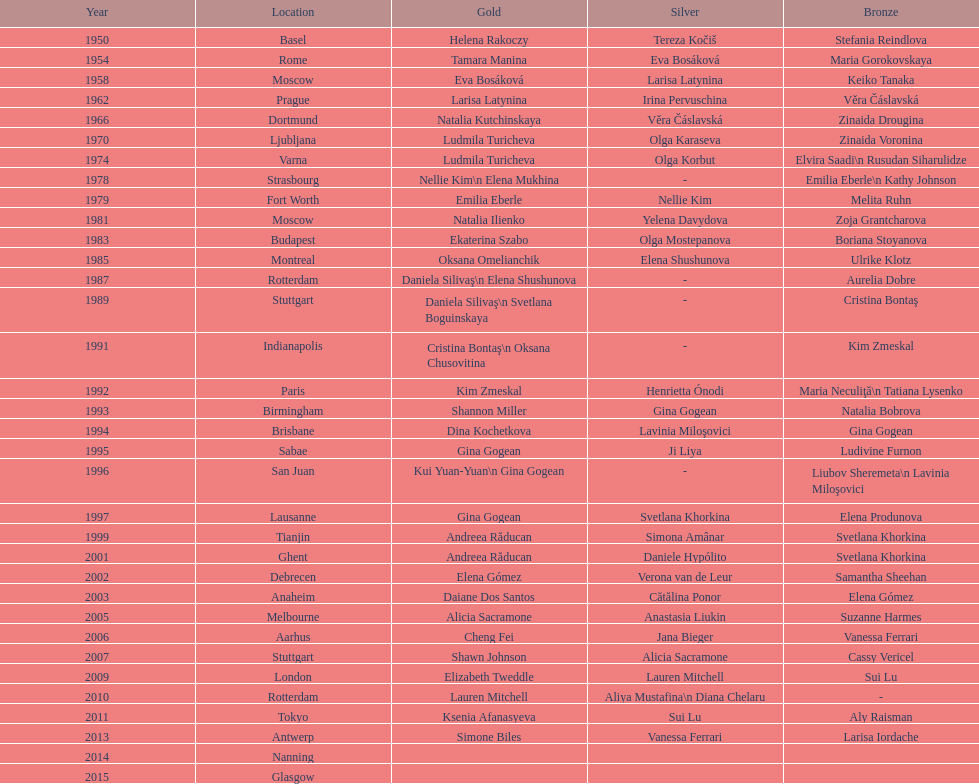What is the duration between the instances when the championship took place in moscow? 23 years. 